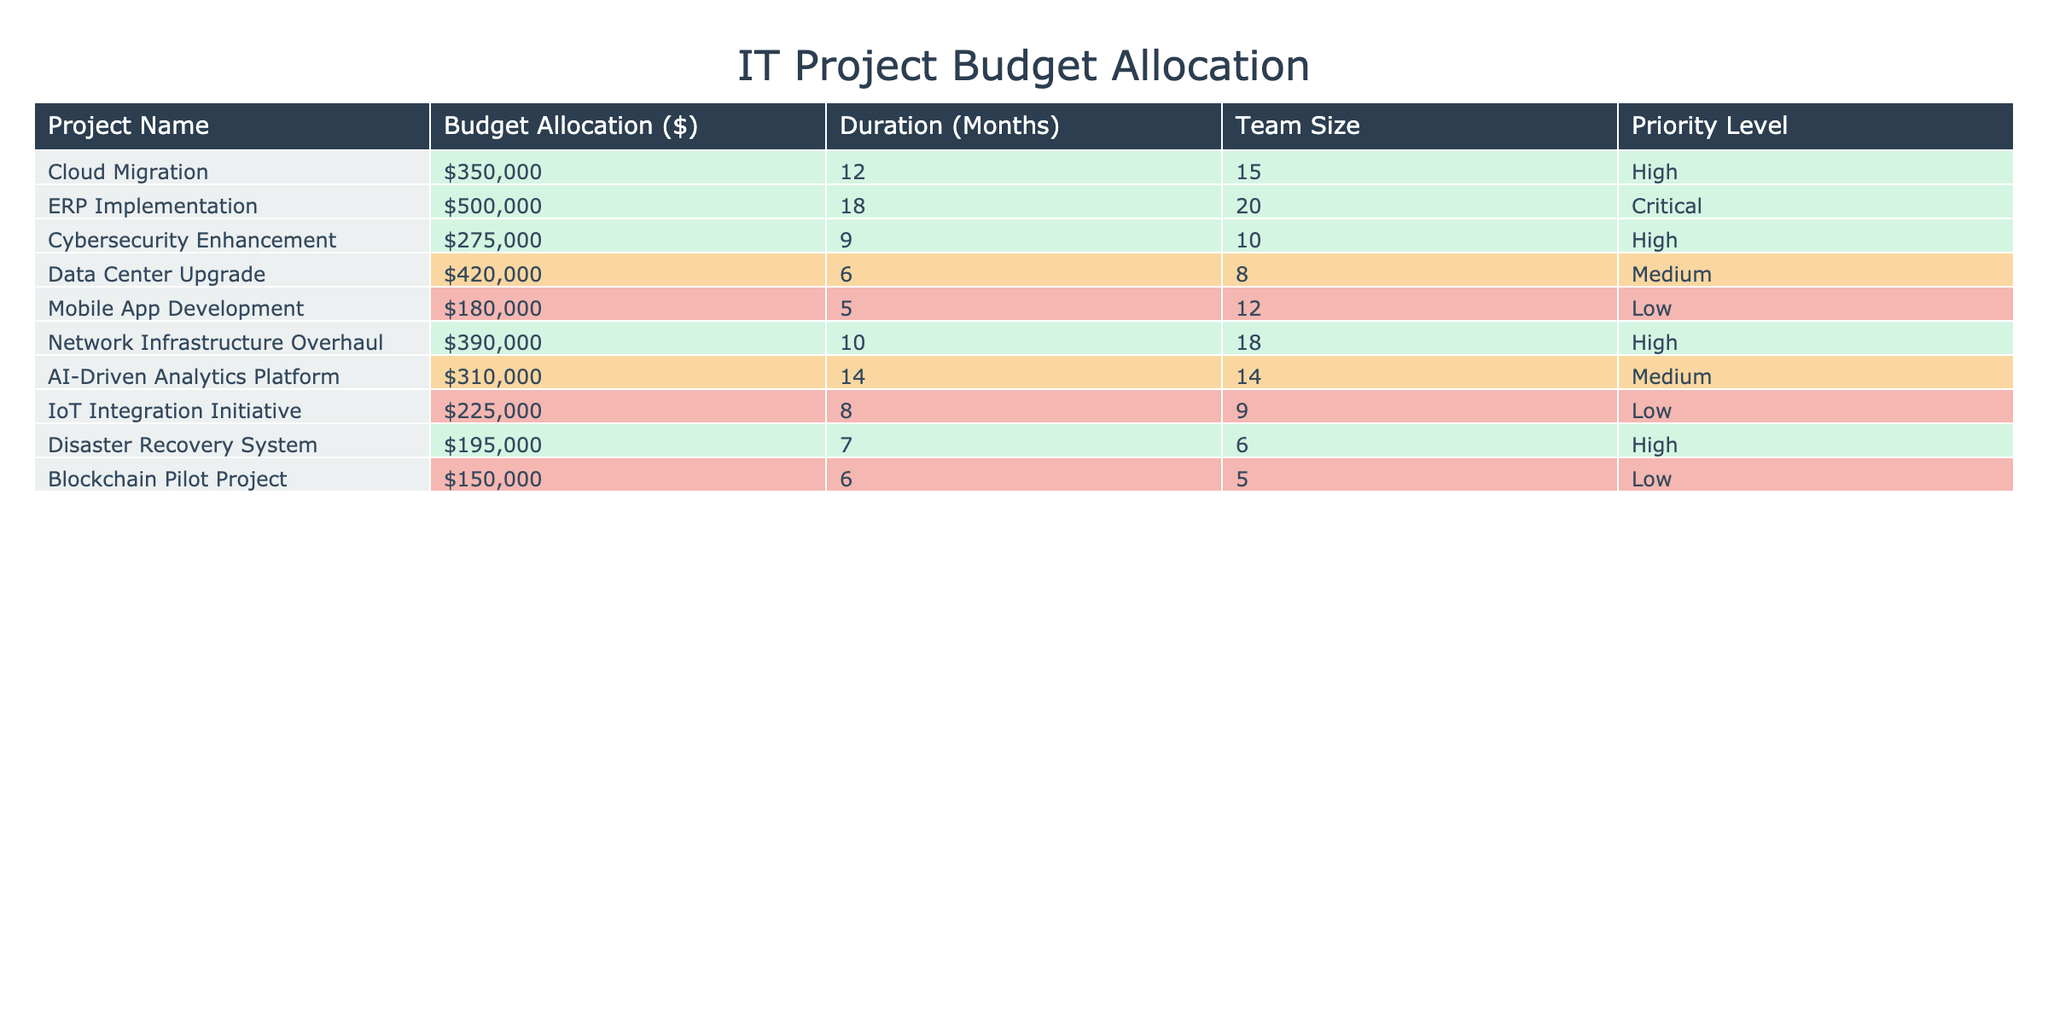What is the highest budget allocation among the projects? By scanning the 'Budget Allocation ($)' column, the highest value is 500000 associated with the 'ERP Implementation' project.
Answer: 500000 Which project has the shortest duration? Checking the 'Duration (Months)' column, the project with the shortest duration is 'Mobile App Development' with 5 months.
Answer: Mobile App Development How many projects have a priority level of "High"? By counting the entries in the 'Priority Level' column that are labeled as "High," there are 4 such projects: 'Cloud Migration', 'Cybersecurity Enhancement', 'Network Infrastructure Overhaul', and 'Disaster Recovery System'.
Answer: 4 What is the total budget allocation for all projects with a "Low" priority level? The total budget for "Low" priority projects includes 'Mobile App Development' (180000), 'IoT Integration Initiative' (225000), and 'Blockchain Pilot Project' (150000), summing to 180000 + 225000 + 150000 = 555000.
Answer: 555000 How does the duration of 'Cloud Migration' compare to that of 'AI-Driven Analytics Platform'? 'Cloud Migration' has a duration of 12 months, while 'AI-Driven Analytics Platform' has a duration of 14 months. 'AI-Driven Analytics Platform' is longer by 2 months.
Answer: 2 months longer What is the average budget allocation for projects with a "Medium" priority level? The 'Medium' priority projects are 'Data Center Upgrade' (420000) and 'AI-Driven Analytics Platform' (310000). The total is 420000 + 310000 = 730000. The average is 730000 / 2 = 365000.
Answer: 365000 Is there any project with a budget allocation lower than 200000? By examining the table, the projects with budgets below 200000 are 'Disaster Recovery System' (195000) and 'Blockchain Pilot Project' (150000). Therefore, the answer is yes.
Answer: Yes Which project has the largest team size? The 'Team Size' column indicates that the project with the largest team is 'ERP Implementation' with 20 members.
Answer: ERP Implementation What is the total budget allocation for all projects completed in less than 10 months? Projects with a duration of less than 10 months are 'Cybersecurity Enhancement' (275000), 'Data Center Upgrade' (420000), 'Mobile App Development' (180000), and 'Disaster Recovery System' (195000). Summing these gives 275000 + 420000 + 180000 + 195000 = 1070000.
Answer: 1070000 How many projects last longer than one year? Looking at the 'Duration (Months)' column, the projects lasting longer than 12 months are 'ERP Implementation' (18 months) and 'Cloud Migration' (12 months). Therefore, the answer is 2.
Answer: 2 